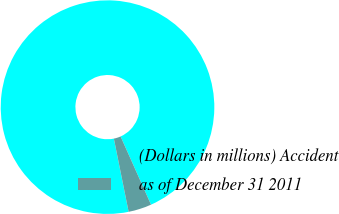Convert chart. <chart><loc_0><loc_0><loc_500><loc_500><pie_chart><fcel>(Dollars in millions) Accident<fcel>as of December 31 2011<nl><fcel>96.49%<fcel>3.51%<nl></chart> 